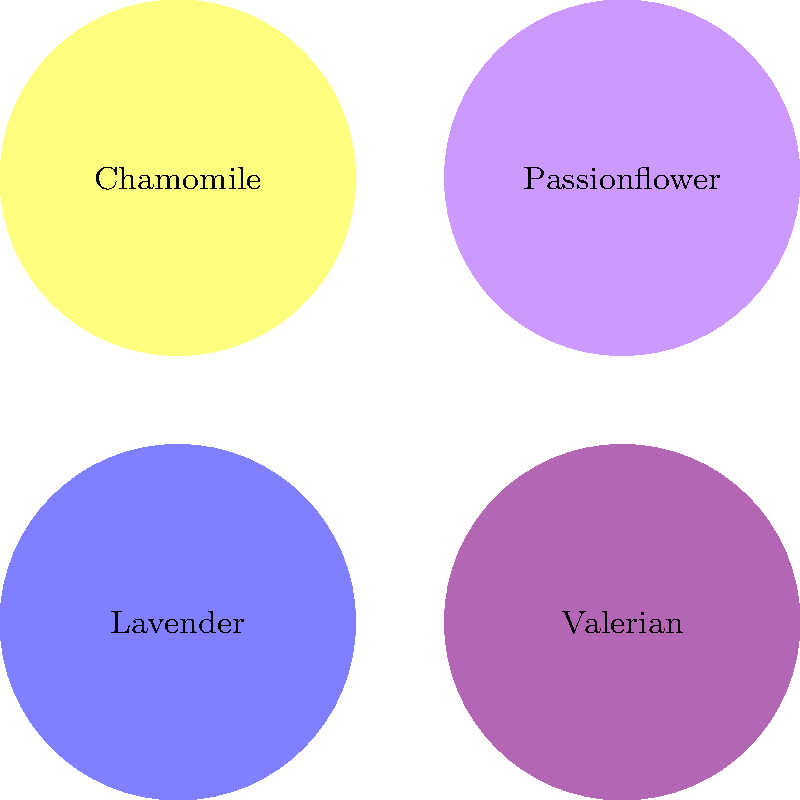Which of the therapeutic plants shown in the image is known for its calming effects and is often used in aromatherapy to promote relaxation and improve sleep quality for individuals with PTSD? To answer this question, let's consider each plant and its properties:

1. Lavender: Known for its calming and soothing effects, lavender is widely used in aromatherapy. It has been shown to reduce anxiety, improve sleep quality, and promote relaxation. These properties make it particularly beneficial for individuals with PTSD.

2. Chamomile: While chamomile is known for its calming properties, it is more commonly used as a tea rather than in aromatherapy. It can help with sleep and anxiety, but it's not as strongly associated with aromatherapy as lavender.

3. Valerian: This plant is primarily used as a sleep aid and is typically consumed as a supplement or tea. It's not commonly used in aromatherapy.

4. Passionflower: While passionflower can help with anxiety and sleep issues, it's usually taken as a supplement or tea, not used in aromatherapy.

Among these options, lavender stands out as the plant most commonly used in aromatherapy for its calming effects, making it particularly beneficial for individuals with PTSD who often struggle with anxiety and sleep disturbances.
Answer: Lavender 